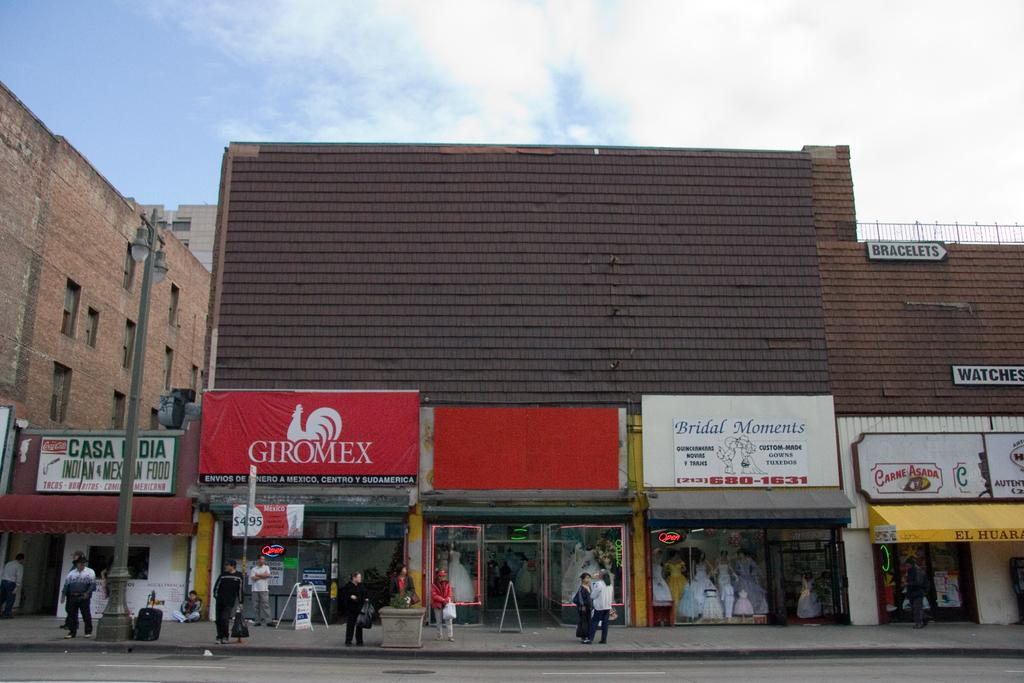Provide a one-sentence caption for the provided image. A series of store fronts, one of which is called Bridal Moments. 